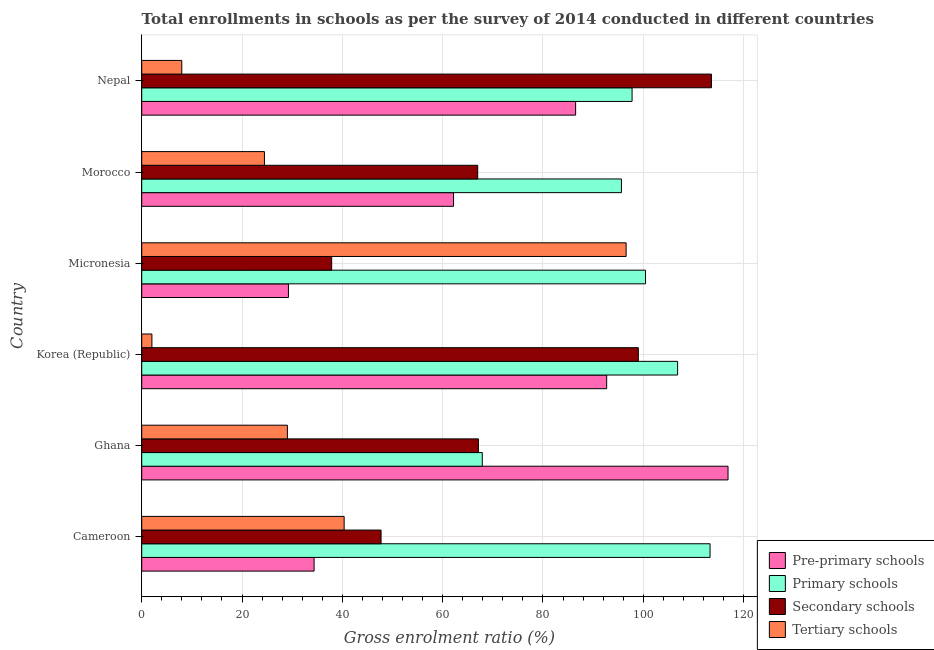How many different coloured bars are there?
Offer a very short reply. 4. How many groups of bars are there?
Your answer should be very brief. 6. Are the number of bars on each tick of the Y-axis equal?
Make the answer very short. Yes. What is the label of the 5th group of bars from the top?
Give a very brief answer. Ghana. In how many cases, is the number of bars for a given country not equal to the number of legend labels?
Give a very brief answer. 0. What is the gross enrolment ratio in tertiary schools in Cameroon?
Your response must be concise. 40.36. Across all countries, what is the maximum gross enrolment ratio in pre-primary schools?
Keep it short and to the point. 116.91. Across all countries, what is the minimum gross enrolment ratio in secondary schools?
Your answer should be compact. 37.87. In which country was the gross enrolment ratio in secondary schools maximum?
Ensure brevity in your answer.  Nepal. What is the total gross enrolment ratio in primary schools in the graph?
Ensure brevity in your answer.  581.96. What is the difference between the gross enrolment ratio in secondary schools in Korea (Republic) and that in Nepal?
Your answer should be very brief. -14.58. What is the difference between the gross enrolment ratio in tertiary schools in Cameroon and the gross enrolment ratio in primary schools in Korea (Republic)?
Your answer should be compact. -66.49. What is the average gross enrolment ratio in pre-primary schools per country?
Offer a terse response. 70.32. What is the difference between the gross enrolment ratio in pre-primary schools and gross enrolment ratio in primary schools in Morocco?
Provide a short and direct response. -33.48. In how many countries, is the gross enrolment ratio in tertiary schools greater than 96 %?
Provide a succinct answer. 1. What is the ratio of the gross enrolment ratio in pre-primary schools in Ghana to that in Micronesia?
Provide a succinct answer. 4. Is the difference between the gross enrolment ratio in primary schools in Ghana and Korea (Republic) greater than the difference between the gross enrolment ratio in tertiary schools in Ghana and Korea (Republic)?
Make the answer very short. No. What is the difference between the highest and the second highest gross enrolment ratio in pre-primary schools?
Make the answer very short. 24.2. What is the difference between the highest and the lowest gross enrolment ratio in pre-primary schools?
Ensure brevity in your answer.  87.65. Is it the case that in every country, the sum of the gross enrolment ratio in tertiary schools and gross enrolment ratio in primary schools is greater than the sum of gross enrolment ratio in pre-primary schools and gross enrolment ratio in secondary schools?
Your answer should be very brief. Yes. What does the 1st bar from the top in Nepal represents?
Give a very brief answer. Tertiary schools. What does the 1st bar from the bottom in Micronesia represents?
Offer a very short reply. Pre-primary schools. How many countries are there in the graph?
Provide a short and direct response. 6. Are the values on the major ticks of X-axis written in scientific E-notation?
Make the answer very short. No. Does the graph contain grids?
Make the answer very short. Yes. Where does the legend appear in the graph?
Offer a terse response. Bottom right. How many legend labels are there?
Ensure brevity in your answer.  4. What is the title of the graph?
Keep it short and to the point. Total enrollments in schools as per the survey of 2014 conducted in different countries. What is the label or title of the X-axis?
Keep it short and to the point. Gross enrolment ratio (%). What is the Gross enrolment ratio (%) of Pre-primary schools in Cameroon?
Offer a terse response. 34.37. What is the Gross enrolment ratio (%) in Primary schools in Cameroon?
Make the answer very short. 113.32. What is the Gross enrolment ratio (%) of Secondary schools in Cameroon?
Your answer should be very brief. 47.72. What is the Gross enrolment ratio (%) in Tertiary schools in Cameroon?
Your response must be concise. 40.36. What is the Gross enrolment ratio (%) in Pre-primary schools in Ghana?
Make the answer very short. 116.91. What is the Gross enrolment ratio (%) in Primary schools in Ghana?
Keep it short and to the point. 67.91. What is the Gross enrolment ratio (%) in Secondary schools in Ghana?
Offer a very short reply. 67.13. What is the Gross enrolment ratio (%) of Tertiary schools in Ghana?
Ensure brevity in your answer.  29.05. What is the Gross enrolment ratio (%) of Pre-primary schools in Korea (Republic)?
Your answer should be very brief. 92.71. What is the Gross enrolment ratio (%) in Primary schools in Korea (Republic)?
Your answer should be compact. 106.85. What is the Gross enrolment ratio (%) in Secondary schools in Korea (Republic)?
Give a very brief answer. 99.02. What is the Gross enrolment ratio (%) in Tertiary schools in Korea (Republic)?
Your answer should be compact. 2.03. What is the Gross enrolment ratio (%) in Pre-primary schools in Micronesia?
Your answer should be very brief. 29.25. What is the Gross enrolment ratio (%) in Primary schools in Micronesia?
Provide a succinct answer. 100.46. What is the Gross enrolment ratio (%) of Secondary schools in Micronesia?
Offer a terse response. 37.87. What is the Gross enrolment ratio (%) of Tertiary schools in Micronesia?
Your response must be concise. 96.58. What is the Gross enrolment ratio (%) in Pre-primary schools in Morocco?
Offer a terse response. 62.17. What is the Gross enrolment ratio (%) in Primary schools in Morocco?
Keep it short and to the point. 95.65. What is the Gross enrolment ratio (%) in Secondary schools in Morocco?
Your response must be concise. 66.99. What is the Gross enrolment ratio (%) of Tertiary schools in Morocco?
Ensure brevity in your answer.  24.47. What is the Gross enrolment ratio (%) of Pre-primary schools in Nepal?
Offer a very short reply. 86.52. What is the Gross enrolment ratio (%) of Primary schools in Nepal?
Offer a terse response. 97.77. What is the Gross enrolment ratio (%) of Secondary schools in Nepal?
Make the answer very short. 113.6. What is the Gross enrolment ratio (%) in Tertiary schools in Nepal?
Your answer should be compact. 7.99. Across all countries, what is the maximum Gross enrolment ratio (%) in Pre-primary schools?
Provide a short and direct response. 116.91. Across all countries, what is the maximum Gross enrolment ratio (%) of Primary schools?
Provide a short and direct response. 113.32. Across all countries, what is the maximum Gross enrolment ratio (%) in Secondary schools?
Make the answer very short. 113.6. Across all countries, what is the maximum Gross enrolment ratio (%) in Tertiary schools?
Your response must be concise. 96.58. Across all countries, what is the minimum Gross enrolment ratio (%) in Pre-primary schools?
Keep it short and to the point. 29.25. Across all countries, what is the minimum Gross enrolment ratio (%) of Primary schools?
Make the answer very short. 67.91. Across all countries, what is the minimum Gross enrolment ratio (%) of Secondary schools?
Your answer should be compact. 37.87. Across all countries, what is the minimum Gross enrolment ratio (%) of Tertiary schools?
Your response must be concise. 2.03. What is the total Gross enrolment ratio (%) of Pre-primary schools in the graph?
Your answer should be very brief. 421.93. What is the total Gross enrolment ratio (%) in Primary schools in the graph?
Your answer should be very brief. 581.96. What is the total Gross enrolment ratio (%) of Secondary schools in the graph?
Make the answer very short. 432.34. What is the total Gross enrolment ratio (%) of Tertiary schools in the graph?
Provide a short and direct response. 200.48. What is the difference between the Gross enrolment ratio (%) in Pre-primary schools in Cameroon and that in Ghana?
Offer a terse response. -82.54. What is the difference between the Gross enrolment ratio (%) in Primary schools in Cameroon and that in Ghana?
Provide a short and direct response. 45.42. What is the difference between the Gross enrolment ratio (%) in Secondary schools in Cameroon and that in Ghana?
Your answer should be very brief. -19.41. What is the difference between the Gross enrolment ratio (%) of Tertiary schools in Cameroon and that in Ghana?
Make the answer very short. 11.32. What is the difference between the Gross enrolment ratio (%) in Pre-primary schools in Cameroon and that in Korea (Republic)?
Offer a terse response. -58.34. What is the difference between the Gross enrolment ratio (%) of Primary schools in Cameroon and that in Korea (Republic)?
Offer a very short reply. 6.47. What is the difference between the Gross enrolment ratio (%) in Secondary schools in Cameroon and that in Korea (Republic)?
Give a very brief answer. -51.3. What is the difference between the Gross enrolment ratio (%) of Tertiary schools in Cameroon and that in Korea (Republic)?
Keep it short and to the point. 38.33. What is the difference between the Gross enrolment ratio (%) of Pre-primary schools in Cameroon and that in Micronesia?
Offer a very short reply. 5.12. What is the difference between the Gross enrolment ratio (%) of Primary schools in Cameroon and that in Micronesia?
Provide a short and direct response. 12.87. What is the difference between the Gross enrolment ratio (%) of Secondary schools in Cameroon and that in Micronesia?
Provide a succinct answer. 9.85. What is the difference between the Gross enrolment ratio (%) of Tertiary schools in Cameroon and that in Micronesia?
Your answer should be compact. -56.22. What is the difference between the Gross enrolment ratio (%) of Pre-primary schools in Cameroon and that in Morocco?
Ensure brevity in your answer.  -27.8. What is the difference between the Gross enrolment ratio (%) of Primary schools in Cameroon and that in Morocco?
Make the answer very short. 17.67. What is the difference between the Gross enrolment ratio (%) in Secondary schools in Cameroon and that in Morocco?
Your answer should be compact. -19.27. What is the difference between the Gross enrolment ratio (%) of Tertiary schools in Cameroon and that in Morocco?
Provide a short and direct response. 15.89. What is the difference between the Gross enrolment ratio (%) in Pre-primary schools in Cameroon and that in Nepal?
Provide a short and direct response. -52.15. What is the difference between the Gross enrolment ratio (%) of Primary schools in Cameroon and that in Nepal?
Your response must be concise. 15.55. What is the difference between the Gross enrolment ratio (%) in Secondary schools in Cameroon and that in Nepal?
Make the answer very short. -65.88. What is the difference between the Gross enrolment ratio (%) in Tertiary schools in Cameroon and that in Nepal?
Ensure brevity in your answer.  32.37. What is the difference between the Gross enrolment ratio (%) in Pre-primary schools in Ghana and that in Korea (Republic)?
Make the answer very short. 24.2. What is the difference between the Gross enrolment ratio (%) in Primary schools in Ghana and that in Korea (Republic)?
Make the answer very short. -38.95. What is the difference between the Gross enrolment ratio (%) of Secondary schools in Ghana and that in Korea (Republic)?
Ensure brevity in your answer.  -31.89. What is the difference between the Gross enrolment ratio (%) in Tertiary schools in Ghana and that in Korea (Republic)?
Offer a very short reply. 27.02. What is the difference between the Gross enrolment ratio (%) of Pre-primary schools in Ghana and that in Micronesia?
Offer a terse response. 87.65. What is the difference between the Gross enrolment ratio (%) in Primary schools in Ghana and that in Micronesia?
Offer a terse response. -32.55. What is the difference between the Gross enrolment ratio (%) of Secondary schools in Ghana and that in Micronesia?
Make the answer very short. 29.26. What is the difference between the Gross enrolment ratio (%) of Tertiary schools in Ghana and that in Micronesia?
Offer a terse response. -67.54. What is the difference between the Gross enrolment ratio (%) of Pre-primary schools in Ghana and that in Morocco?
Ensure brevity in your answer.  54.73. What is the difference between the Gross enrolment ratio (%) in Primary schools in Ghana and that in Morocco?
Make the answer very short. -27.74. What is the difference between the Gross enrolment ratio (%) in Secondary schools in Ghana and that in Morocco?
Your answer should be very brief. 0.14. What is the difference between the Gross enrolment ratio (%) of Tertiary schools in Ghana and that in Morocco?
Give a very brief answer. 4.58. What is the difference between the Gross enrolment ratio (%) in Pre-primary schools in Ghana and that in Nepal?
Offer a terse response. 30.39. What is the difference between the Gross enrolment ratio (%) in Primary schools in Ghana and that in Nepal?
Offer a very short reply. -29.87. What is the difference between the Gross enrolment ratio (%) of Secondary schools in Ghana and that in Nepal?
Provide a short and direct response. -46.46. What is the difference between the Gross enrolment ratio (%) of Tertiary schools in Ghana and that in Nepal?
Provide a succinct answer. 21.06. What is the difference between the Gross enrolment ratio (%) in Pre-primary schools in Korea (Republic) and that in Micronesia?
Your answer should be very brief. 63.45. What is the difference between the Gross enrolment ratio (%) of Primary schools in Korea (Republic) and that in Micronesia?
Ensure brevity in your answer.  6.4. What is the difference between the Gross enrolment ratio (%) in Secondary schools in Korea (Republic) and that in Micronesia?
Provide a short and direct response. 61.15. What is the difference between the Gross enrolment ratio (%) in Tertiary schools in Korea (Republic) and that in Micronesia?
Offer a terse response. -94.55. What is the difference between the Gross enrolment ratio (%) in Pre-primary schools in Korea (Republic) and that in Morocco?
Offer a terse response. 30.53. What is the difference between the Gross enrolment ratio (%) of Primary schools in Korea (Republic) and that in Morocco?
Ensure brevity in your answer.  11.2. What is the difference between the Gross enrolment ratio (%) of Secondary schools in Korea (Republic) and that in Morocco?
Provide a succinct answer. 32.03. What is the difference between the Gross enrolment ratio (%) in Tertiary schools in Korea (Republic) and that in Morocco?
Provide a short and direct response. -22.44. What is the difference between the Gross enrolment ratio (%) of Pre-primary schools in Korea (Republic) and that in Nepal?
Keep it short and to the point. 6.19. What is the difference between the Gross enrolment ratio (%) in Primary schools in Korea (Republic) and that in Nepal?
Offer a very short reply. 9.08. What is the difference between the Gross enrolment ratio (%) in Secondary schools in Korea (Republic) and that in Nepal?
Give a very brief answer. -14.58. What is the difference between the Gross enrolment ratio (%) in Tertiary schools in Korea (Republic) and that in Nepal?
Make the answer very short. -5.96. What is the difference between the Gross enrolment ratio (%) of Pre-primary schools in Micronesia and that in Morocco?
Your answer should be very brief. -32.92. What is the difference between the Gross enrolment ratio (%) in Primary schools in Micronesia and that in Morocco?
Your answer should be compact. 4.81. What is the difference between the Gross enrolment ratio (%) of Secondary schools in Micronesia and that in Morocco?
Your response must be concise. -29.12. What is the difference between the Gross enrolment ratio (%) of Tertiary schools in Micronesia and that in Morocco?
Provide a short and direct response. 72.12. What is the difference between the Gross enrolment ratio (%) of Pre-primary schools in Micronesia and that in Nepal?
Make the answer very short. -57.26. What is the difference between the Gross enrolment ratio (%) in Primary schools in Micronesia and that in Nepal?
Offer a very short reply. 2.68. What is the difference between the Gross enrolment ratio (%) in Secondary schools in Micronesia and that in Nepal?
Make the answer very short. -75.72. What is the difference between the Gross enrolment ratio (%) of Tertiary schools in Micronesia and that in Nepal?
Provide a short and direct response. 88.6. What is the difference between the Gross enrolment ratio (%) in Pre-primary schools in Morocco and that in Nepal?
Your answer should be compact. -24.34. What is the difference between the Gross enrolment ratio (%) of Primary schools in Morocco and that in Nepal?
Provide a short and direct response. -2.12. What is the difference between the Gross enrolment ratio (%) of Secondary schools in Morocco and that in Nepal?
Your response must be concise. -46.61. What is the difference between the Gross enrolment ratio (%) of Tertiary schools in Morocco and that in Nepal?
Give a very brief answer. 16.48. What is the difference between the Gross enrolment ratio (%) of Pre-primary schools in Cameroon and the Gross enrolment ratio (%) of Primary schools in Ghana?
Provide a short and direct response. -33.54. What is the difference between the Gross enrolment ratio (%) of Pre-primary schools in Cameroon and the Gross enrolment ratio (%) of Secondary schools in Ghana?
Keep it short and to the point. -32.76. What is the difference between the Gross enrolment ratio (%) in Pre-primary schools in Cameroon and the Gross enrolment ratio (%) in Tertiary schools in Ghana?
Make the answer very short. 5.32. What is the difference between the Gross enrolment ratio (%) in Primary schools in Cameroon and the Gross enrolment ratio (%) in Secondary schools in Ghana?
Make the answer very short. 46.19. What is the difference between the Gross enrolment ratio (%) in Primary schools in Cameroon and the Gross enrolment ratio (%) in Tertiary schools in Ghana?
Your response must be concise. 84.28. What is the difference between the Gross enrolment ratio (%) in Secondary schools in Cameroon and the Gross enrolment ratio (%) in Tertiary schools in Ghana?
Provide a succinct answer. 18.68. What is the difference between the Gross enrolment ratio (%) of Pre-primary schools in Cameroon and the Gross enrolment ratio (%) of Primary schools in Korea (Republic)?
Offer a terse response. -72.48. What is the difference between the Gross enrolment ratio (%) of Pre-primary schools in Cameroon and the Gross enrolment ratio (%) of Secondary schools in Korea (Republic)?
Keep it short and to the point. -64.65. What is the difference between the Gross enrolment ratio (%) in Pre-primary schools in Cameroon and the Gross enrolment ratio (%) in Tertiary schools in Korea (Republic)?
Offer a very short reply. 32.34. What is the difference between the Gross enrolment ratio (%) in Primary schools in Cameroon and the Gross enrolment ratio (%) in Secondary schools in Korea (Republic)?
Your answer should be very brief. 14.3. What is the difference between the Gross enrolment ratio (%) of Primary schools in Cameroon and the Gross enrolment ratio (%) of Tertiary schools in Korea (Republic)?
Provide a short and direct response. 111.29. What is the difference between the Gross enrolment ratio (%) of Secondary schools in Cameroon and the Gross enrolment ratio (%) of Tertiary schools in Korea (Republic)?
Ensure brevity in your answer.  45.69. What is the difference between the Gross enrolment ratio (%) of Pre-primary schools in Cameroon and the Gross enrolment ratio (%) of Primary schools in Micronesia?
Your answer should be compact. -66.09. What is the difference between the Gross enrolment ratio (%) of Pre-primary schools in Cameroon and the Gross enrolment ratio (%) of Secondary schools in Micronesia?
Offer a very short reply. -3.5. What is the difference between the Gross enrolment ratio (%) in Pre-primary schools in Cameroon and the Gross enrolment ratio (%) in Tertiary schools in Micronesia?
Give a very brief answer. -62.22. What is the difference between the Gross enrolment ratio (%) in Primary schools in Cameroon and the Gross enrolment ratio (%) in Secondary schools in Micronesia?
Offer a terse response. 75.45. What is the difference between the Gross enrolment ratio (%) in Primary schools in Cameroon and the Gross enrolment ratio (%) in Tertiary schools in Micronesia?
Offer a very short reply. 16.74. What is the difference between the Gross enrolment ratio (%) of Secondary schools in Cameroon and the Gross enrolment ratio (%) of Tertiary schools in Micronesia?
Keep it short and to the point. -48.86. What is the difference between the Gross enrolment ratio (%) in Pre-primary schools in Cameroon and the Gross enrolment ratio (%) in Primary schools in Morocco?
Provide a succinct answer. -61.28. What is the difference between the Gross enrolment ratio (%) in Pre-primary schools in Cameroon and the Gross enrolment ratio (%) in Secondary schools in Morocco?
Your answer should be compact. -32.62. What is the difference between the Gross enrolment ratio (%) of Pre-primary schools in Cameroon and the Gross enrolment ratio (%) of Tertiary schools in Morocco?
Offer a very short reply. 9.9. What is the difference between the Gross enrolment ratio (%) in Primary schools in Cameroon and the Gross enrolment ratio (%) in Secondary schools in Morocco?
Your response must be concise. 46.33. What is the difference between the Gross enrolment ratio (%) in Primary schools in Cameroon and the Gross enrolment ratio (%) in Tertiary schools in Morocco?
Your answer should be very brief. 88.85. What is the difference between the Gross enrolment ratio (%) of Secondary schools in Cameroon and the Gross enrolment ratio (%) of Tertiary schools in Morocco?
Offer a very short reply. 23.25. What is the difference between the Gross enrolment ratio (%) of Pre-primary schools in Cameroon and the Gross enrolment ratio (%) of Primary schools in Nepal?
Provide a succinct answer. -63.4. What is the difference between the Gross enrolment ratio (%) of Pre-primary schools in Cameroon and the Gross enrolment ratio (%) of Secondary schools in Nepal?
Offer a very short reply. -79.23. What is the difference between the Gross enrolment ratio (%) in Pre-primary schools in Cameroon and the Gross enrolment ratio (%) in Tertiary schools in Nepal?
Your answer should be very brief. 26.38. What is the difference between the Gross enrolment ratio (%) of Primary schools in Cameroon and the Gross enrolment ratio (%) of Secondary schools in Nepal?
Keep it short and to the point. -0.28. What is the difference between the Gross enrolment ratio (%) in Primary schools in Cameroon and the Gross enrolment ratio (%) in Tertiary schools in Nepal?
Make the answer very short. 105.33. What is the difference between the Gross enrolment ratio (%) in Secondary schools in Cameroon and the Gross enrolment ratio (%) in Tertiary schools in Nepal?
Your response must be concise. 39.73. What is the difference between the Gross enrolment ratio (%) in Pre-primary schools in Ghana and the Gross enrolment ratio (%) in Primary schools in Korea (Republic)?
Ensure brevity in your answer.  10.05. What is the difference between the Gross enrolment ratio (%) of Pre-primary schools in Ghana and the Gross enrolment ratio (%) of Secondary schools in Korea (Republic)?
Your answer should be very brief. 17.89. What is the difference between the Gross enrolment ratio (%) of Pre-primary schools in Ghana and the Gross enrolment ratio (%) of Tertiary schools in Korea (Republic)?
Your answer should be very brief. 114.88. What is the difference between the Gross enrolment ratio (%) of Primary schools in Ghana and the Gross enrolment ratio (%) of Secondary schools in Korea (Republic)?
Make the answer very short. -31.11. What is the difference between the Gross enrolment ratio (%) of Primary schools in Ghana and the Gross enrolment ratio (%) of Tertiary schools in Korea (Republic)?
Your answer should be very brief. 65.88. What is the difference between the Gross enrolment ratio (%) in Secondary schools in Ghana and the Gross enrolment ratio (%) in Tertiary schools in Korea (Republic)?
Give a very brief answer. 65.1. What is the difference between the Gross enrolment ratio (%) of Pre-primary schools in Ghana and the Gross enrolment ratio (%) of Primary schools in Micronesia?
Your answer should be compact. 16.45. What is the difference between the Gross enrolment ratio (%) in Pre-primary schools in Ghana and the Gross enrolment ratio (%) in Secondary schools in Micronesia?
Offer a very short reply. 79.03. What is the difference between the Gross enrolment ratio (%) in Pre-primary schools in Ghana and the Gross enrolment ratio (%) in Tertiary schools in Micronesia?
Your answer should be compact. 20.32. What is the difference between the Gross enrolment ratio (%) in Primary schools in Ghana and the Gross enrolment ratio (%) in Secondary schools in Micronesia?
Your answer should be compact. 30.03. What is the difference between the Gross enrolment ratio (%) of Primary schools in Ghana and the Gross enrolment ratio (%) of Tertiary schools in Micronesia?
Make the answer very short. -28.68. What is the difference between the Gross enrolment ratio (%) of Secondary schools in Ghana and the Gross enrolment ratio (%) of Tertiary schools in Micronesia?
Your response must be concise. -29.45. What is the difference between the Gross enrolment ratio (%) of Pre-primary schools in Ghana and the Gross enrolment ratio (%) of Primary schools in Morocco?
Provide a short and direct response. 21.26. What is the difference between the Gross enrolment ratio (%) in Pre-primary schools in Ghana and the Gross enrolment ratio (%) in Secondary schools in Morocco?
Your answer should be very brief. 49.91. What is the difference between the Gross enrolment ratio (%) in Pre-primary schools in Ghana and the Gross enrolment ratio (%) in Tertiary schools in Morocco?
Keep it short and to the point. 92.44. What is the difference between the Gross enrolment ratio (%) in Primary schools in Ghana and the Gross enrolment ratio (%) in Secondary schools in Morocco?
Ensure brevity in your answer.  0.91. What is the difference between the Gross enrolment ratio (%) of Primary schools in Ghana and the Gross enrolment ratio (%) of Tertiary schools in Morocco?
Offer a very short reply. 43.44. What is the difference between the Gross enrolment ratio (%) of Secondary schools in Ghana and the Gross enrolment ratio (%) of Tertiary schools in Morocco?
Provide a short and direct response. 42.67. What is the difference between the Gross enrolment ratio (%) of Pre-primary schools in Ghana and the Gross enrolment ratio (%) of Primary schools in Nepal?
Your answer should be very brief. 19.13. What is the difference between the Gross enrolment ratio (%) in Pre-primary schools in Ghana and the Gross enrolment ratio (%) in Secondary schools in Nepal?
Your response must be concise. 3.31. What is the difference between the Gross enrolment ratio (%) of Pre-primary schools in Ghana and the Gross enrolment ratio (%) of Tertiary schools in Nepal?
Ensure brevity in your answer.  108.92. What is the difference between the Gross enrolment ratio (%) of Primary schools in Ghana and the Gross enrolment ratio (%) of Secondary schools in Nepal?
Your answer should be compact. -45.69. What is the difference between the Gross enrolment ratio (%) in Primary schools in Ghana and the Gross enrolment ratio (%) in Tertiary schools in Nepal?
Provide a succinct answer. 59.92. What is the difference between the Gross enrolment ratio (%) of Secondary schools in Ghana and the Gross enrolment ratio (%) of Tertiary schools in Nepal?
Your answer should be compact. 59.15. What is the difference between the Gross enrolment ratio (%) of Pre-primary schools in Korea (Republic) and the Gross enrolment ratio (%) of Primary schools in Micronesia?
Ensure brevity in your answer.  -7.75. What is the difference between the Gross enrolment ratio (%) in Pre-primary schools in Korea (Republic) and the Gross enrolment ratio (%) in Secondary schools in Micronesia?
Offer a terse response. 54.83. What is the difference between the Gross enrolment ratio (%) in Pre-primary schools in Korea (Republic) and the Gross enrolment ratio (%) in Tertiary schools in Micronesia?
Offer a very short reply. -3.88. What is the difference between the Gross enrolment ratio (%) in Primary schools in Korea (Republic) and the Gross enrolment ratio (%) in Secondary schools in Micronesia?
Ensure brevity in your answer.  68.98. What is the difference between the Gross enrolment ratio (%) in Primary schools in Korea (Republic) and the Gross enrolment ratio (%) in Tertiary schools in Micronesia?
Your answer should be very brief. 10.27. What is the difference between the Gross enrolment ratio (%) in Secondary schools in Korea (Republic) and the Gross enrolment ratio (%) in Tertiary schools in Micronesia?
Offer a terse response. 2.43. What is the difference between the Gross enrolment ratio (%) in Pre-primary schools in Korea (Republic) and the Gross enrolment ratio (%) in Primary schools in Morocco?
Make the answer very short. -2.94. What is the difference between the Gross enrolment ratio (%) in Pre-primary schools in Korea (Republic) and the Gross enrolment ratio (%) in Secondary schools in Morocco?
Offer a terse response. 25.71. What is the difference between the Gross enrolment ratio (%) in Pre-primary schools in Korea (Republic) and the Gross enrolment ratio (%) in Tertiary schools in Morocco?
Make the answer very short. 68.24. What is the difference between the Gross enrolment ratio (%) of Primary schools in Korea (Republic) and the Gross enrolment ratio (%) of Secondary schools in Morocco?
Offer a very short reply. 39.86. What is the difference between the Gross enrolment ratio (%) of Primary schools in Korea (Republic) and the Gross enrolment ratio (%) of Tertiary schools in Morocco?
Ensure brevity in your answer.  82.38. What is the difference between the Gross enrolment ratio (%) in Secondary schools in Korea (Republic) and the Gross enrolment ratio (%) in Tertiary schools in Morocco?
Your response must be concise. 74.55. What is the difference between the Gross enrolment ratio (%) of Pre-primary schools in Korea (Republic) and the Gross enrolment ratio (%) of Primary schools in Nepal?
Keep it short and to the point. -5.07. What is the difference between the Gross enrolment ratio (%) in Pre-primary schools in Korea (Republic) and the Gross enrolment ratio (%) in Secondary schools in Nepal?
Provide a short and direct response. -20.89. What is the difference between the Gross enrolment ratio (%) of Pre-primary schools in Korea (Republic) and the Gross enrolment ratio (%) of Tertiary schools in Nepal?
Ensure brevity in your answer.  84.72. What is the difference between the Gross enrolment ratio (%) of Primary schools in Korea (Republic) and the Gross enrolment ratio (%) of Secondary schools in Nepal?
Your answer should be compact. -6.74. What is the difference between the Gross enrolment ratio (%) of Primary schools in Korea (Republic) and the Gross enrolment ratio (%) of Tertiary schools in Nepal?
Ensure brevity in your answer.  98.87. What is the difference between the Gross enrolment ratio (%) of Secondary schools in Korea (Republic) and the Gross enrolment ratio (%) of Tertiary schools in Nepal?
Provide a short and direct response. 91.03. What is the difference between the Gross enrolment ratio (%) in Pre-primary schools in Micronesia and the Gross enrolment ratio (%) in Primary schools in Morocco?
Your response must be concise. -66.4. What is the difference between the Gross enrolment ratio (%) in Pre-primary schools in Micronesia and the Gross enrolment ratio (%) in Secondary schools in Morocco?
Provide a short and direct response. -37.74. What is the difference between the Gross enrolment ratio (%) of Pre-primary schools in Micronesia and the Gross enrolment ratio (%) of Tertiary schools in Morocco?
Offer a very short reply. 4.79. What is the difference between the Gross enrolment ratio (%) of Primary schools in Micronesia and the Gross enrolment ratio (%) of Secondary schools in Morocco?
Your answer should be compact. 33.46. What is the difference between the Gross enrolment ratio (%) in Primary schools in Micronesia and the Gross enrolment ratio (%) in Tertiary schools in Morocco?
Ensure brevity in your answer.  75.99. What is the difference between the Gross enrolment ratio (%) in Secondary schools in Micronesia and the Gross enrolment ratio (%) in Tertiary schools in Morocco?
Provide a succinct answer. 13.41. What is the difference between the Gross enrolment ratio (%) of Pre-primary schools in Micronesia and the Gross enrolment ratio (%) of Primary schools in Nepal?
Your answer should be compact. -68.52. What is the difference between the Gross enrolment ratio (%) of Pre-primary schools in Micronesia and the Gross enrolment ratio (%) of Secondary schools in Nepal?
Your response must be concise. -84.34. What is the difference between the Gross enrolment ratio (%) in Pre-primary schools in Micronesia and the Gross enrolment ratio (%) in Tertiary schools in Nepal?
Provide a short and direct response. 21.27. What is the difference between the Gross enrolment ratio (%) in Primary schools in Micronesia and the Gross enrolment ratio (%) in Secondary schools in Nepal?
Your answer should be compact. -13.14. What is the difference between the Gross enrolment ratio (%) in Primary schools in Micronesia and the Gross enrolment ratio (%) in Tertiary schools in Nepal?
Keep it short and to the point. 92.47. What is the difference between the Gross enrolment ratio (%) of Secondary schools in Micronesia and the Gross enrolment ratio (%) of Tertiary schools in Nepal?
Your answer should be compact. 29.89. What is the difference between the Gross enrolment ratio (%) in Pre-primary schools in Morocco and the Gross enrolment ratio (%) in Primary schools in Nepal?
Provide a short and direct response. -35.6. What is the difference between the Gross enrolment ratio (%) of Pre-primary schools in Morocco and the Gross enrolment ratio (%) of Secondary schools in Nepal?
Your response must be concise. -51.42. What is the difference between the Gross enrolment ratio (%) in Pre-primary schools in Morocco and the Gross enrolment ratio (%) in Tertiary schools in Nepal?
Give a very brief answer. 54.19. What is the difference between the Gross enrolment ratio (%) of Primary schools in Morocco and the Gross enrolment ratio (%) of Secondary schools in Nepal?
Keep it short and to the point. -17.95. What is the difference between the Gross enrolment ratio (%) in Primary schools in Morocco and the Gross enrolment ratio (%) in Tertiary schools in Nepal?
Your answer should be compact. 87.66. What is the difference between the Gross enrolment ratio (%) in Secondary schools in Morocco and the Gross enrolment ratio (%) in Tertiary schools in Nepal?
Make the answer very short. 59. What is the average Gross enrolment ratio (%) in Pre-primary schools per country?
Keep it short and to the point. 70.32. What is the average Gross enrolment ratio (%) in Primary schools per country?
Make the answer very short. 96.99. What is the average Gross enrolment ratio (%) of Secondary schools per country?
Give a very brief answer. 72.06. What is the average Gross enrolment ratio (%) in Tertiary schools per country?
Offer a very short reply. 33.41. What is the difference between the Gross enrolment ratio (%) in Pre-primary schools and Gross enrolment ratio (%) in Primary schools in Cameroon?
Your answer should be very brief. -78.95. What is the difference between the Gross enrolment ratio (%) of Pre-primary schools and Gross enrolment ratio (%) of Secondary schools in Cameroon?
Offer a very short reply. -13.35. What is the difference between the Gross enrolment ratio (%) of Pre-primary schools and Gross enrolment ratio (%) of Tertiary schools in Cameroon?
Keep it short and to the point. -5.99. What is the difference between the Gross enrolment ratio (%) of Primary schools and Gross enrolment ratio (%) of Secondary schools in Cameroon?
Provide a short and direct response. 65.6. What is the difference between the Gross enrolment ratio (%) in Primary schools and Gross enrolment ratio (%) in Tertiary schools in Cameroon?
Offer a terse response. 72.96. What is the difference between the Gross enrolment ratio (%) in Secondary schools and Gross enrolment ratio (%) in Tertiary schools in Cameroon?
Your answer should be very brief. 7.36. What is the difference between the Gross enrolment ratio (%) of Pre-primary schools and Gross enrolment ratio (%) of Primary schools in Ghana?
Offer a terse response. 49. What is the difference between the Gross enrolment ratio (%) in Pre-primary schools and Gross enrolment ratio (%) in Secondary schools in Ghana?
Your response must be concise. 49.77. What is the difference between the Gross enrolment ratio (%) of Pre-primary schools and Gross enrolment ratio (%) of Tertiary schools in Ghana?
Ensure brevity in your answer.  87.86. What is the difference between the Gross enrolment ratio (%) in Primary schools and Gross enrolment ratio (%) in Secondary schools in Ghana?
Offer a terse response. 0.77. What is the difference between the Gross enrolment ratio (%) in Primary schools and Gross enrolment ratio (%) in Tertiary schools in Ghana?
Offer a terse response. 38.86. What is the difference between the Gross enrolment ratio (%) in Secondary schools and Gross enrolment ratio (%) in Tertiary schools in Ghana?
Provide a succinct answer. 38.09. What is the difference between the Gross enrolment ratio (%) in Pre-primary schools and Gross enrolment ratio (%) in Primary schools in Korea (Republic)?
Make the answer very short. -14.15. What is the difference between the Gross enrolment ratio (%) of Pre-primary schools and Gross enrolment ratio (%) of Secondary schools in Korea (Republic)?
Your answer should be very brief. -6.31. What is the difference between the Gross enrolment ratio (%) of Pre-primary schools and Gross enrolment ratio (%) of Tertiary schools in Korea (Republic)?
Provide a short and direct response. 90.68. What is the difference between the Gross enrolment ratio (%) in Primary schools and Gross enrolment ratio (%) in Secondary schools in Korea (Republic)?
Give a very brief answer. 7.83. What is the difference between the Gross enrolment ratio (%) of Primary schools and Gross enrolment ratio (%) of Tertiary schools in Korea (Republic)?
Offer a terse response. 104.82. What is the difference between the Gross enrolment ratio (%) of Secondary schools and Gross enrolment ratio (%) of Tertiary schools in Korea (Republic)?
Your answer should be compact. 96.99. What is the difference between the Gross enrolment ratio (%) in Pre-primary schools and Gross enrolment ratio (%) in Primary schools in Micronesia?
Offer a terse response. -71.2. What is the difference between the Gross enrolment ratio (%) in Pre-primary schools and Gross enrolment ratio (%) in Secondary schools in Micronesia?
Your answer should be compact. -8.62. What is the difference between the Gross enrolment ratio (%) in Pre-primary schools and Gross enrolment ratio (%) in Tertiary schools in Micronesia?
Your answer should be compact. -67.33. What is the difference between the Gross enrolment ratio (%) in Primary schools and Gross enrolment ratio (%) in Secondary schools in Micronesia?
Make the answer very short. 62.58. What is the difference between the Gross enrolment ratio (%) of Primary schools and Gross enrolment ratio (%) of Tertiary schools in Micronesia?
Keep it short and to the point. 3.87. What is the difference between the Gross enrolment ratio (%) of Secondary schools and Gross enrolment ratio (%) of Tertiary schools in Micronesia?
Your answer should be very brief. -58.71. What is the difference between the Gross enrolment ratio (%) of Pre-primary schools and Gross enrolment ratio (%) of Primary schools in Morocco?
Provide a succinct answer. -33.48. What is the difference between the Gross enrolment ratio (%) of Pre-primary schools and Gross enrolment ratio (%) of Secondary schools in Morocco?
Your answer should be very brief. -4.82. What is the difference between the Gross enrolment ratio (%) of Pre-primary schools and Gross enrolment ratio (%) of Tertiary schools in Morocco?
Ensure brevity in your answer.  37.71. What is the difference between the Gross enrolment ratio (%) of Primary schools and Gross enrolment ratio (%) of Secondary schools in Morocco?
Keep it short and to the point. 28.66. What is the difference between the Gross enrolment ratio (%) of Primary schools and Gross enrolment ratio (%) of Tertiary schools in Morocco?
Give a very brief answer. 71.18. What is the difference between the Gross enrolment ratio (%) in Secondary schools and Gross enrolment ratio (%) in Tertiary schools in Morocco?
Your response must be concise. 42.52. What is the difference between the Gross enrolment ratio (%) in Pre-primary schools and Gross enrolment ratio (%) in Primary schools in Nepal?
Offer a terse response. -11.25. What is the difference between the Gross enrolment ratio (%) in Pre-primary schools and Gross enrolment ratio (%) in Secondary schools in Nepal?
Keep it short and to the point. -27.08. What is the difference between the Gross enrolment ratio (%) in Pre-primary schools and Gross enrolment ratio (%) in Tertiary schools in Nepal?
Your response must be concise. 78.53. What is the difference between the Gross enrolment ratio (%) in Primary schools and Gross enrolment ratio (%) in Secondary schools in Nepal?
Your response must be concise. -15.83. What is the difference between the Gross enrolment ratio (%) in Primary schools and Gross enrolment ratio (%) in Tertiary schools in Nepal?
Provide a succinct answer. 89.78. What is the difference between the Gross enrolment ratio (%) in Secondary schools and Gross enrolment ratio (%) in Tertiary schools in Nepal?
Offer a terse response. 105.61. What is the ratio of the Gross enrolment ratio (%) in Pre-primary schools in Cameroon to that in Ghana?
Keep it short and to the point. 0.29. What is the ratio of the Gross enrolment ratio (%) in Primary schools in Cameroon to that in Ghana?
Give a very brief answer. 1.67. What is the ratio of the Gross enrolment ratio (%) in Secondary schools in Cameroon to that in Ghana?
Provide a succinct answer. 0.71. What is the ratio of the Gross enrolment ratio (%) in Tertiary schools in Cameroon to that in Ghana?
Offer a terse response. 1.39. What is the ratio of the Gross enrolment ratio (%) of Pre-primary schools in Cameroon to that in Korea (Republic)?
Your response must be concise. 0.37. What is the ratio of the Gross enrolment ratio (%) in Primary schools in Cameroon to that in Korea (Republic)?
Your answer should be compact. 1.06. What is the ratio of the Gross enrolment ratio (%) of Secondary schools in Cameroon to that in Korea (Republic)?
Ensure brevity in your answer.  0.48. What is the ratio of the Gross enrolment ratio (%) of Tertiary schools in Cameroon to that in Korea (Republic)?
Your answer should be very brief. 19.88. What is the ratio of the Gross enrolment ratio (%) in Pre-primary schools in Cameroon to that in Micronesia?
Give a very brief answer. 1.17. What is the ratio of the Gross enrolment ratio (%) in Primary schools in Cameroon to that in Micronesia?
Give a very brief answer. 1.13. What is the ratio of the Gross enrolment ratio (%) in Secondary schools in Cameroon to that in Micronesia?
Keep it short and to the point. 1.26. What is the ratio of the Gross enrolment ratio (%) in Tertiary schools in Cameroon to that in Micronesia?
Give a very brief answer. 0.42. What is the ratio of the Gross enrolment ratio (%) of Pre-primary schools in Cameroon to that in Morocco?
Make the answer very short. 0.55. What is the ratio of the Gross enrolment ratio (%) in Primary schools in Cameroon to that in Morocco?
Provide a short and direct response. 1.18. What is the ratio of the Gross enrolment ratio (%) of Secondary schools in Cameroon to that in Morocco?
Provide a short and direct response. 0.71. What is the ratio of the Gross enrolment ratio (%) in Tertiary schools in Cameroon to that in Morocco?
Provide a short and direct response. 1.65. What is the ratio of the Gross enrolment ratio (%) in Pre-primary schools in Cameroon to that in Nepal?
Your answer should be very brief. 0.4. What is the ratio of the Gross enrolment ratio (%) of Primary schools in Cameroon to that in Nepal?
Provide a short and direct response. 1.16. What is the ratio of the Gross enrolment ratio (%) of Secondary schools in Cameroon to that in Nepal?
Your answer should be very brief. 0.42. What is the ratio of the Gross enrolment ratio (%) in Tertiary schools in Cameroon to that in Nepal?
Ensure brevity in your answer.  5.05. What is the ratio of the Gross enrolment ratio (%) of Pre-primary schools in Ghana to that in Korea (Republic)?
Offer a very short reply. 1.26. What is the ratio of the Gross enrolment ratio (%) of Primary schools in Ghana to that in Korea (Republic)?
Provide a short and direct response. 0.64. What is the ratio of the Gross enrolment ratio (%) in Secondary schools in Ghana to that in Korea (Republic)?
Offer a terse response. 0.68. What is the ratio of the Gross enrolment ratio (%) in Tertiary schools in Ghana to that in Korea (Republic)?
Make the answer very short. 14.3. What is the ratio of the Gross enrolment ratio (%) of Pre-primary schools in Ghana to that in Micronesia?
Offer a terse response. 4. What is the ratio of the Gross enrolment ratio (%) in Primary schools in Ghana to that in Micronesia?
Offer a terse response. 0.68. What is the ratio of the Gross enrolment ratio (%) of Secondary schools in Ghana to that in Micronesia?
Provide a short and direct response. 1.77. What is the ratio of the Gross enrolment ratio (%) of Tertiary schools in Ghana to that in Micronesia?
Your response must be concise. 0.3. What is the ratio of the Gross enrolment ratio (%) in Pre-primary schools in Ghana to that in Morocco?
Offer a very short reply. 1.88. What is the ratio of the Gross enrolment ratio (%) of Primary schools in Ghana to that in Morocco?
Your answer should be compact. 0.71. What is the ratio of the Gross enrolment ratio (%) in Tertiary schools in Ghana to that in Morocco?
Your answer should be compact. 1.19. What is the ratio of the Gross enrolment ratio (%) in Pre-primary schools in Ghana to that in Nepal?
Offer a very short reply. 1.35. What is the ratio of the Gross enrolment ratio (%) of Primary schools in Ghana to that in Nepal?
Offer a very short reply. 0.69. What is the ratio of the Gross enrolment ratio (%) of Secondary schools in Ghana to that in Nepal?
Provide a short and direct response. 0.59. What is the ratio of the Gross enrolment ratio (%) in Tertiary schools in Ghana to that in Nepal?
Offer a terse response. 3.64. What is the ratio of the Gross enrolment ratio (%) in Pre-primary schools in Korea (Republic) to that in Micronesia?
Make the answer very short. 3.17. What is the ratio of the Gross enrolment ratio (%) of Primary schools in Korea (Republic) to that in Micronesia?
Your response must be concise. 1.06. What is the ratio of the Gross enrolment ratio (%) of Secondary schools in Korea (Republic) to that in Micronesia?
Offer a terse response. 2.61. What is the ratio of the Gross enrolment ratio (%) of Tertiary schools in Korea (Republic) to that in Micronesia?
Your answer should be very brief. 0.02. What is the ratio of the Gross enrolment ratio (%) in Pre-primary schools in Korea (Republic) to that in Morocco?
Your answer should be very brief. 1.49. What is the ratio of the Gross enrolment ratio (%) in Primary schools in Korea (Republic) to that in Morocco?
Make the answer very short. 1.12. What is the ratio of the Gross enrolment ratio (%) in Secondary schools in Korea (Republic) to that in Morocco?
Ensure brevity in your answer.  1.48. What is the ratio of the Gross enrolment ratio (%) in Tertiary schools in Korea (Republic) to that in Morocco?
Keep it short and to the point. 0.08. What is the ratio of the Gross enrolment ratio (%) of Pre-primary schools in Korea (Republic) to that in Nepal?
Your answer should be very brief. 1.07. What is the ratio of the Gross enrolment ratio (%) in Primary schools in Korea (Republic) to that in Nepal?
Provide a short and direct response. 1.09. What is the ratio of the Gross enrolment ratio (%) of Secondary schools in Korea (Republic) to that in Nepal?
Ensure brevity in your answer.  0.87. What is the ratio of the Gross enrolment ratio (%) in Tertiary schools in Korea (Republic) to that in Nepal?
Ensure brevity in your answer.  0.25. What is the ratio of the Gross enrolment ratio (%) of Pre-primary schools in Micronesia to that in Morocco?
Make the answer very short. 0.47. What is the ratio of the Gross enrolment ratio (%) in Primary schools in Micronesia to that in Morocco?
Give a very brief answer. 1.05. What is the ratio of the Gross enrolment ratio (%) in Secondary schools in Micronesia to that in Morocco?
Your answer should be very brief. 0.57. What is the ratio of the Gross enrolment ratio (%) in Tertiary schools in Micronesia to that in Morocco?
Your response must be concise. 3.95. What is the ratio of the Gross enrolment ratio (%) in Pre-primary schools in Micronesia to that in Nepal?
Ensure brevity in your answer.  0.34. What is the ratio of the Gross enrolment ratio (%) of Primary schools in Micronesia to that in Nepal?
Give a very brief answer. 1.03. What is the ratio of the Gross enrolment ratio (%) of Secondary schools in Micronesia to that in Nepal?
Provide a short and direct response. 0.33. What is the ratio of the Gross enrolment ratio (%) in Tertiary schools in Micronesia to that in Nepal?
Give a very brief answer. 12.09. What is the ratio of the Gross enrolment ratio (%) of Pre-primary schools in Morocco to that in Nepal?
Your answer should be very brief. 0.72. What is the ratio of the Gross enrolment ratio (%) of Primary schools in Morocco to that in Nepal?
Offer a very short reply. 0.98. What is the ratio of the Gross enrolment ratio (%) in Secondary schools in Morocco to that in Nepal?
Ensure brevity in your answer.  0.59. What is the ratio of the Gross enrolment ratio (%) of Tertiary schools in Morocco to that in Nepal?
Make the answer very short. 3.06. What is the difference between the highest and the second highest Gross enrolment ratio (%) of Pre-primary schools?
Offer a terse response. 24.2. What is the difference between the highest and the second highest Gross enrolment ratio (%) in Primary schools?
Offer a very short reply. 6.47. What is the difference between the highest and the second highest Gross enrolment ratio (%) of Secondary schools?
Provide a short and direct response. 14.58. What is the difference between the highest and the second highest Gross enrolment ratio (%) in Tertiary schools?
Offer a terse response. 56.22. What is the difference between the highest and the lowest Gross enrolment ratio (%) in Pre-primary schools?
Provide a short and direct response. 87.65. What is the difference between the highest and the lowest Gross enrolment ratio (%) of Primary schools?
Provide a short and direct response. 45.42. What is the difference between the highest and the lowest Gross enrolment ratio (%) of Secondary schools?
Offer a very short reply. 75.72. What is the difference between the highest and the lowest Gross enrolment ratio (%) in Tertiary schools?
Offer a very short reply. 94.55. 